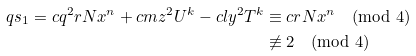<formula> <loc_0><loc_0><loc_500><loc_500>q s _ { 1 } = c q ^ { 2 } r N x ^ { n } + c m z ^ { 2 } U ^ { k } - c l y ^ { 2 } T ^ { k } & \equiv c r N x ^ { n } \pmod { 4 } \\ & \not \equiv 2 \pmod { 4 }</formula> 